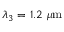<formula> <loc_0><loc_0><loc_500><loc_500>\lambda _ { 3 } = 1 . 2 \mu m</formula> 